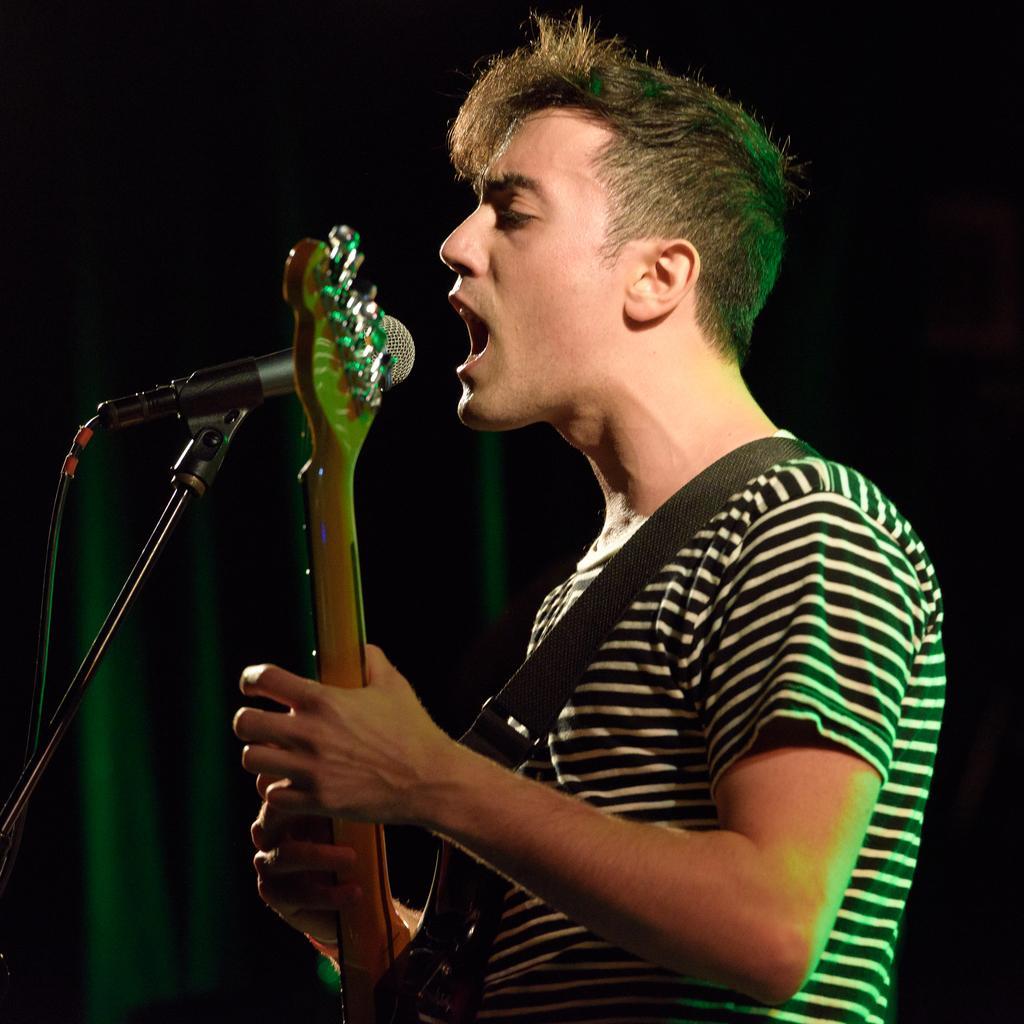Can you describe this image briefly? This picture consists of a man standing and singing in front of the mic. Holding a musical instrument in his hand. 